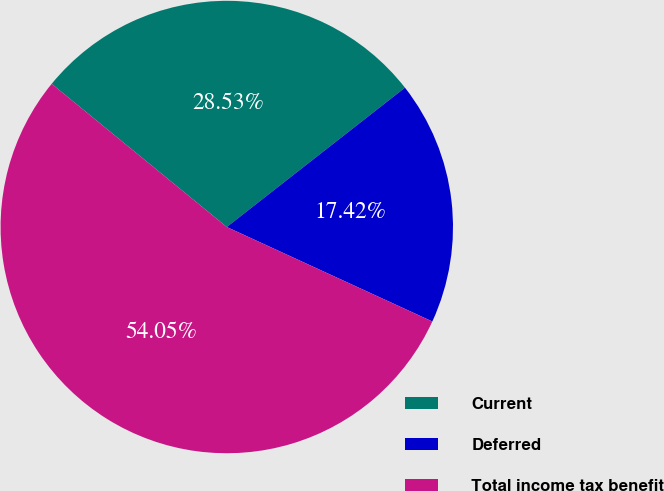Convert chart to OTSL. <chart><loc_0><loc_0><loc_500><loc_500><pie_chart><fcel>Current<fcel>Deferred<fcel>Total income tax benefit<nl><fcel>28.53%<fcel>17.42%<fcel>54.05%<nl></chart> 